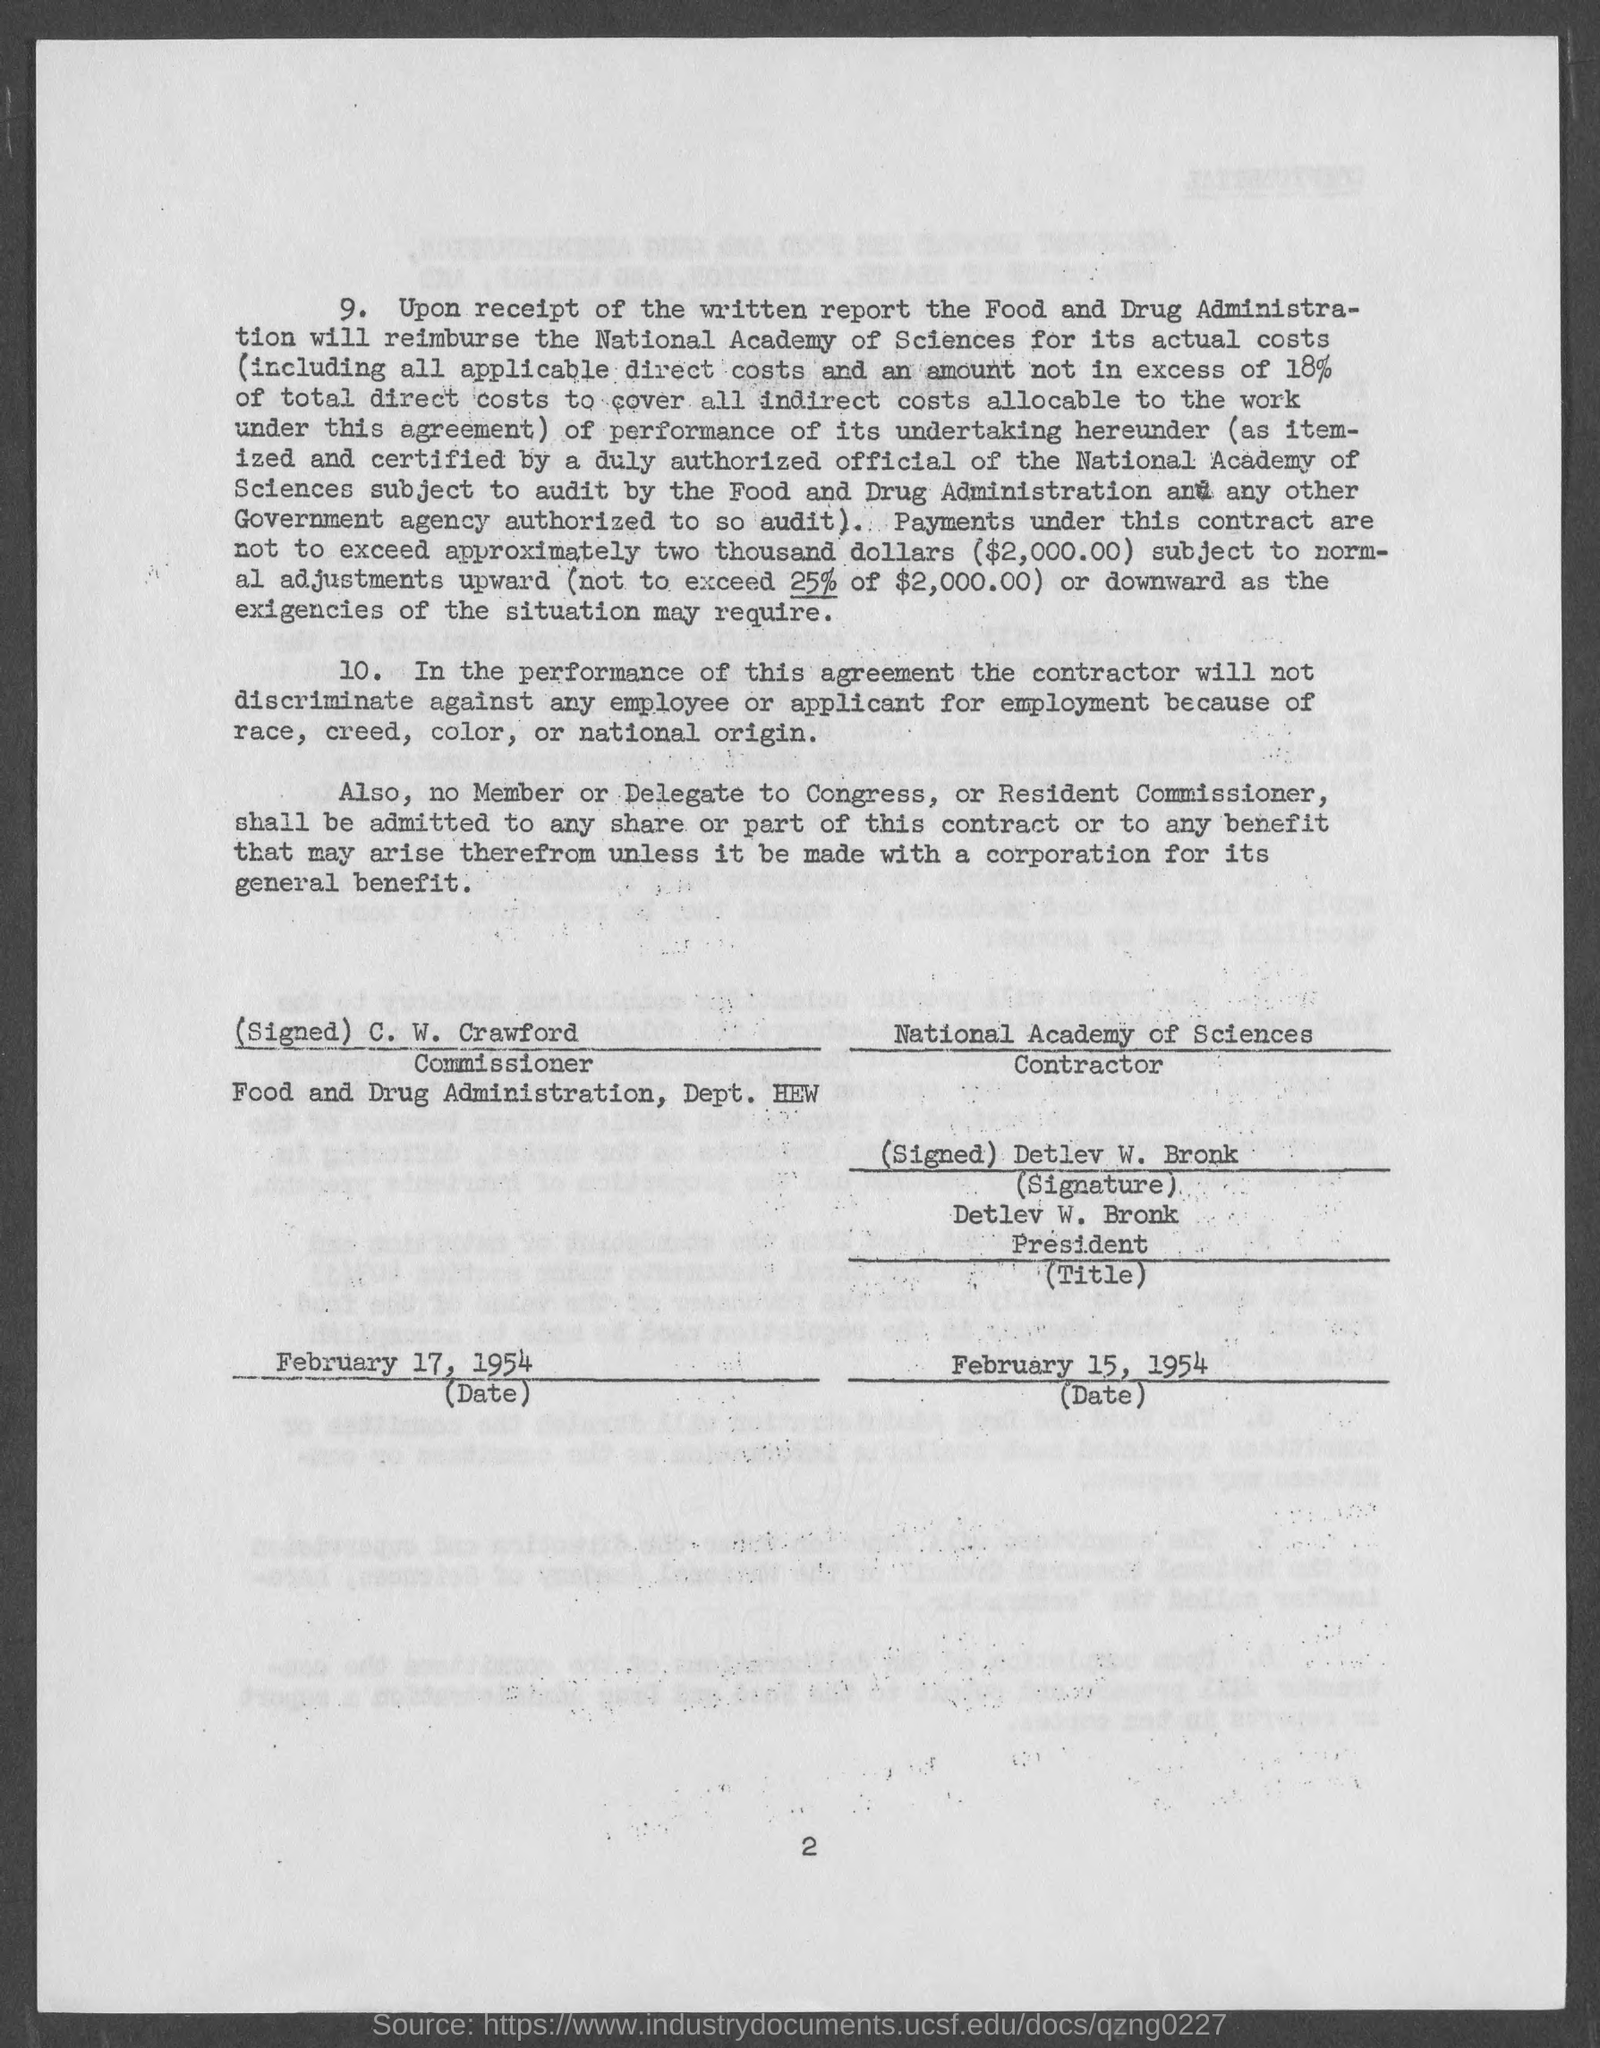Mention a couple of crucial points in this snapshot. The person identified as the Commissioner is C. W. Crawford. The National Academy of Sciences is the contractor. The National Academy of Sciences will be reimbursed for its actual costs by the Food and Drug Administration. 